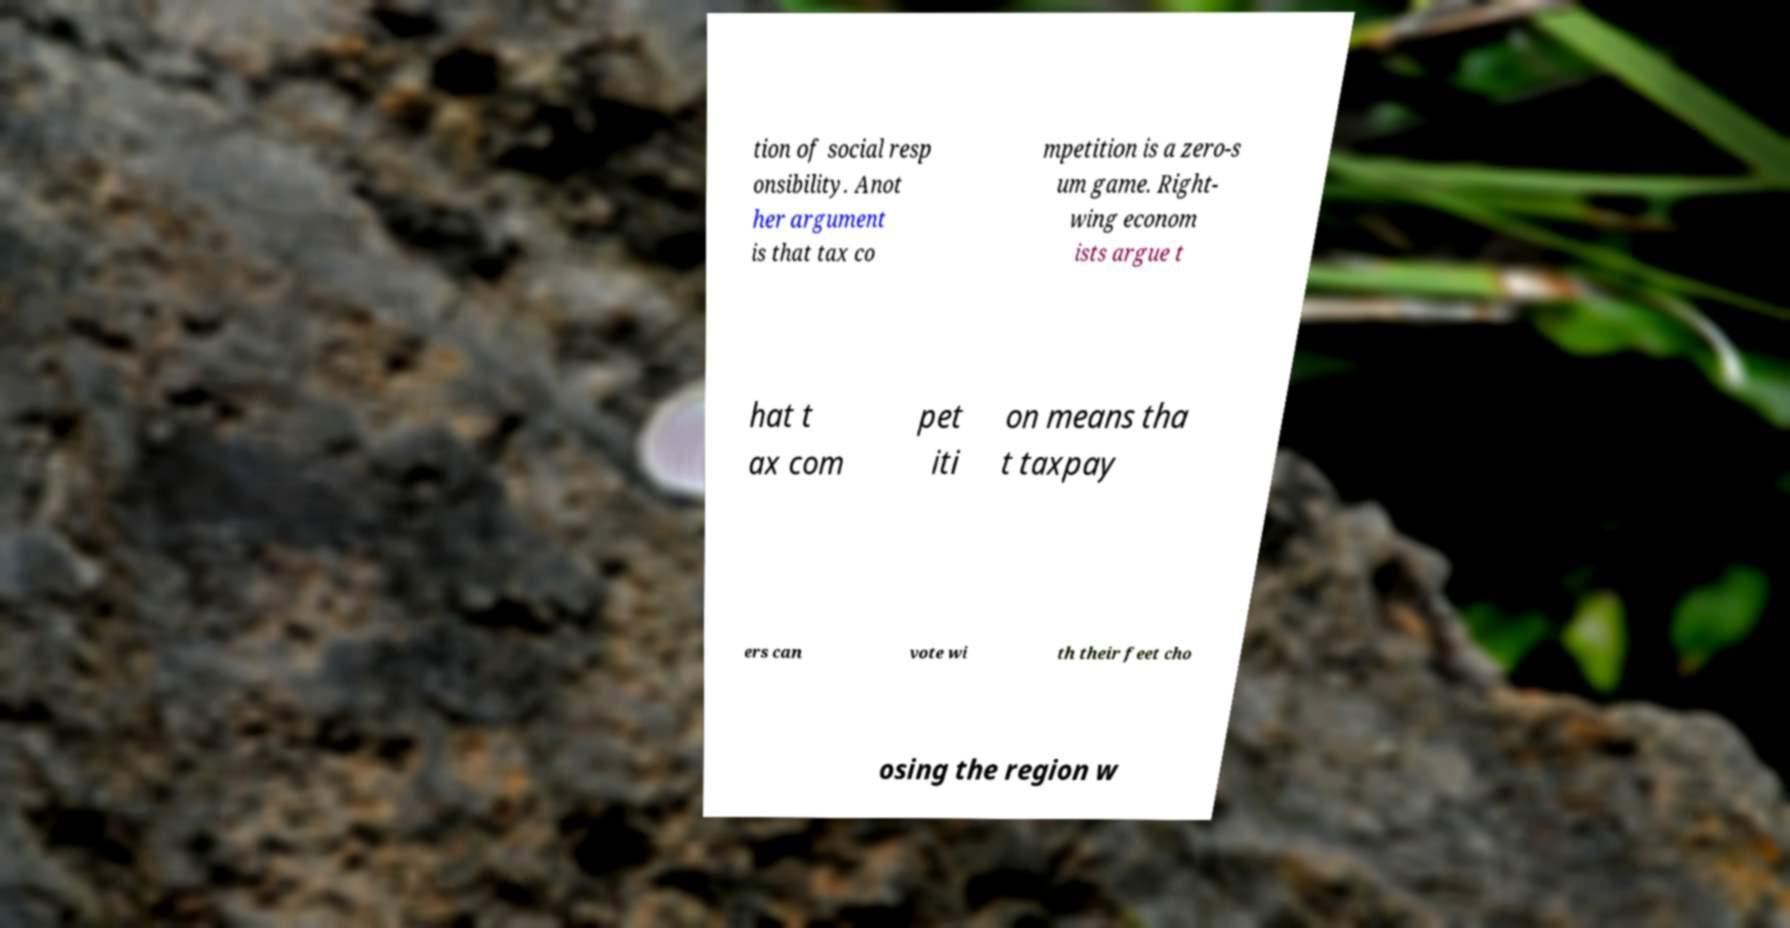Can you read and provide the text displayed in the image?This photo seems to have some interesting text. Can you extract and type it out for me? tion of social resp onsibility. Anot her argument is that tax co mpetition is a zero-s um game. Right- wing econom ists argue t hat t ax com pet iti on means tha t taxpay ers can vote wi th their feet cho osing the region w 